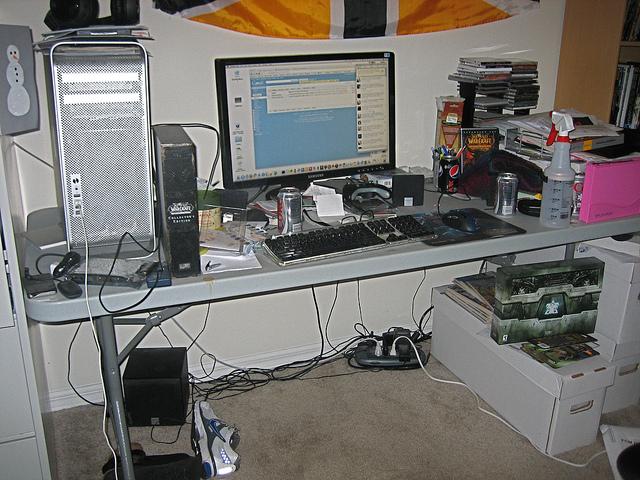What color is the object to the right of the spray bottle?
Be succinct. Pink. How many computers are shown?
Be succinct. 1. What breath freshener is on the desk?
Quick response, please. None. What is the silver object to the left?
Quick response, please. Computer. Is there pink in this picture?
Give a very brief answer. Yes. What room is this?
Give a very brief answer. Office. Who makes this type of computer?
Quick response, please. Dell. What type of computer is this?
Give a very brief answer. Desktop. What kind of computers are there?
Quick response, please. Dell. 